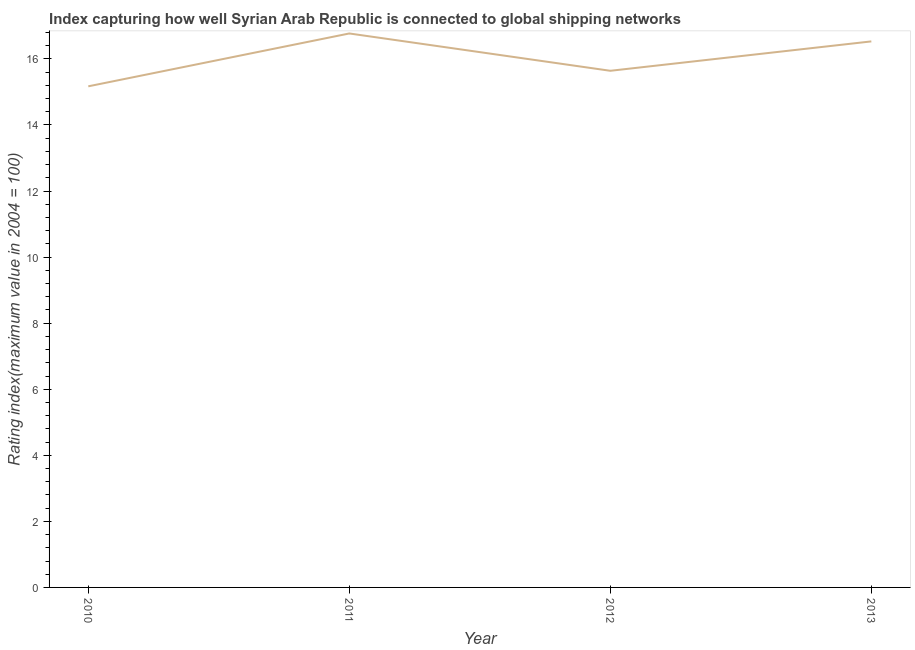What is the liner shipping connectivity index in 2013?
Provide a succinct answer. 16.53. Across all years, what is the maximum liner shipping connectivity index?
Offer a terse response. 16.77. Across all years, what is the minimum liner shipping connectivity index?
Keep it short and to the point. 15.17. What is the sum of the liner shipping connectivity index?
Give a very brief answer. 64.11. What is the difference between the liner shipping connectivity index in 2012 and 2013?
Provide a short and direct response. -0.89. What is the average liner shipping connectivity index per year?
Ensure brevity in your answer.  16.03. What is the median liner shipping connectivity index?
Your response must be concise. 16.09. What is the ratio of the liner shipping connectivity index in 2010 to that in 2011?
Your answer should be compact. 0.9. Is the liner shipping connectivity index in 2011 less than that in 2013?
Provide a short and direct response. No. Is the difference between the liner shipping connectivity index in 2011 and 2013 greater than the difference between any two years?
Provide a short and direct response. No. What is the difference between the highest and the second highest liner shipping connectivity index?
Provide a succinct answer. 0.24. Is the sum of the liner shipping connectivity index in 2011 and 2012 greater than the maximum liner shipping connectivity index across all years?
Make the answer very short. Yes. What is the difference between the highest and the lowest liner shipping connectivity index?
Provide a short and direct response. 1.6. In how many years, is the liner shipping connectivity index greater than the average liner shipping connectivity index taken over all years?
Make the answer very short. 2. How many lines are there?
Your answer should be compact. 1. How many years are there in the graph?
Offer a very short reply. 4. What is the difference between two consecutive major ticks on the Y-axis?
Offer a terse response. 2. Are the values on the major ticks of Y-axis written in scientific E-notation?
Offer a terse response. No. Does the graph contain any zero values?
Provide a succinct answer. No. What is the title of the graph?
Your answer should be very brief. Index capturing how well Syrian Arab Republic is connected to global shipping networks. What is the label or title of the Y-axis?
Your answer should be compact. Rating index(maximum value in 2004 = 100). What is the Rating index(maximum value in 2004 = 100) in 2010?
Your response must be concise. 15.17. What is the Rating index(maximum value in 2004 = 100) in 2011?
Keep it short and to the point. 16.77. What is the Rating index(maximum value in 2004 = 100) in 2012?
Provide a short and direct response. 15.64. What is the Rating index(maximum value in 2004 = 100) of 2013?
Your answer should be compact. 16.53. What is the difference between the Rating index(maximum value in 2004 = 100) in 2010 and 2011?
Keep it short and to the point. -1.6. What is the difference between the Rating index(maximum value in 2004 = 100) in 2010 and 2012?
Your answer should be very brief. -0.47. What is the difference between the Rating index(maximum value in 2004 = 100) in 2010 and 2013?
Your answer should be compact. -1.36. What is the difference between the Rating index(maximum value in 2004 = 100) in 2011 and 2012?
Your response must be concise. 1.13. What is the difference between the Rating index(maximum value in 2004 = 100) in 2011 and 2013?
Your answer should be very brief. 0.24. What is the difference between the Rating index(maximum value in 2004 = 100) in 2012 and 2013?
Your answer should be very brief. -0.89. What is the ratio of the Rating index(maximum value in 2004 = 100) in 2010 to that in 2011?
Your response must be concise. 0.91. What is the ratio of the Rating index(maximum value in 2004 = 100) in 2010 to that in 2012?
Offer a very short reply. 0.97. What is the ratio of the Rating index(maximum value in 2004 = 100) in 2010 to that in 2013?
Offer a very short reply. 0.92. What is the ratio of the Rating index(maximum value in 2004 = 100) in 2011 to that in 2012?
Offer a terse response. 1.07. What is the ratio of the Rating index(maximum value in 2004 = 100) in 2012 to that in 2013?
Give a very brief answer. 0.95. 